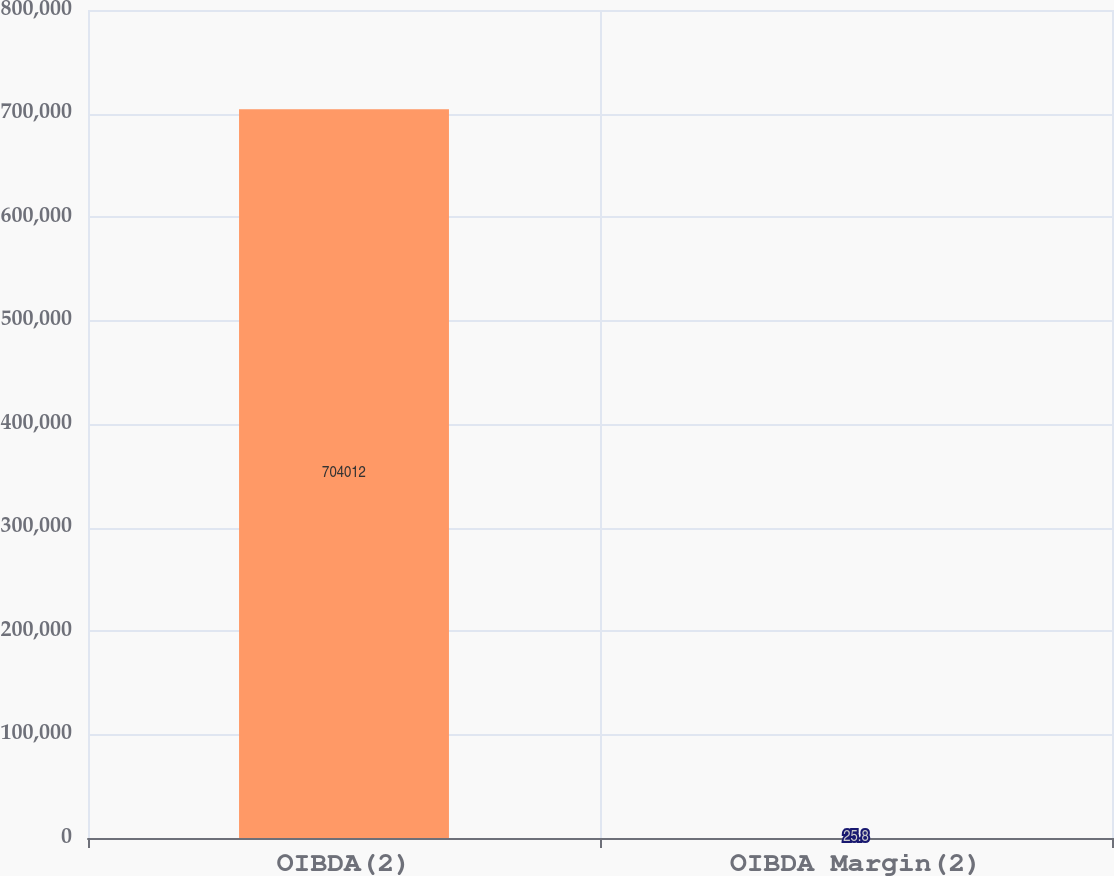Convert chart to OTSL. <chart><loc_0><loc_0><loc_500><loc_500><bar_chart><fcel>OIBDA(2)<fcel>OIBDA Margin(2)<nl><fcel>704012<fcel>25.8<nl></chart> 